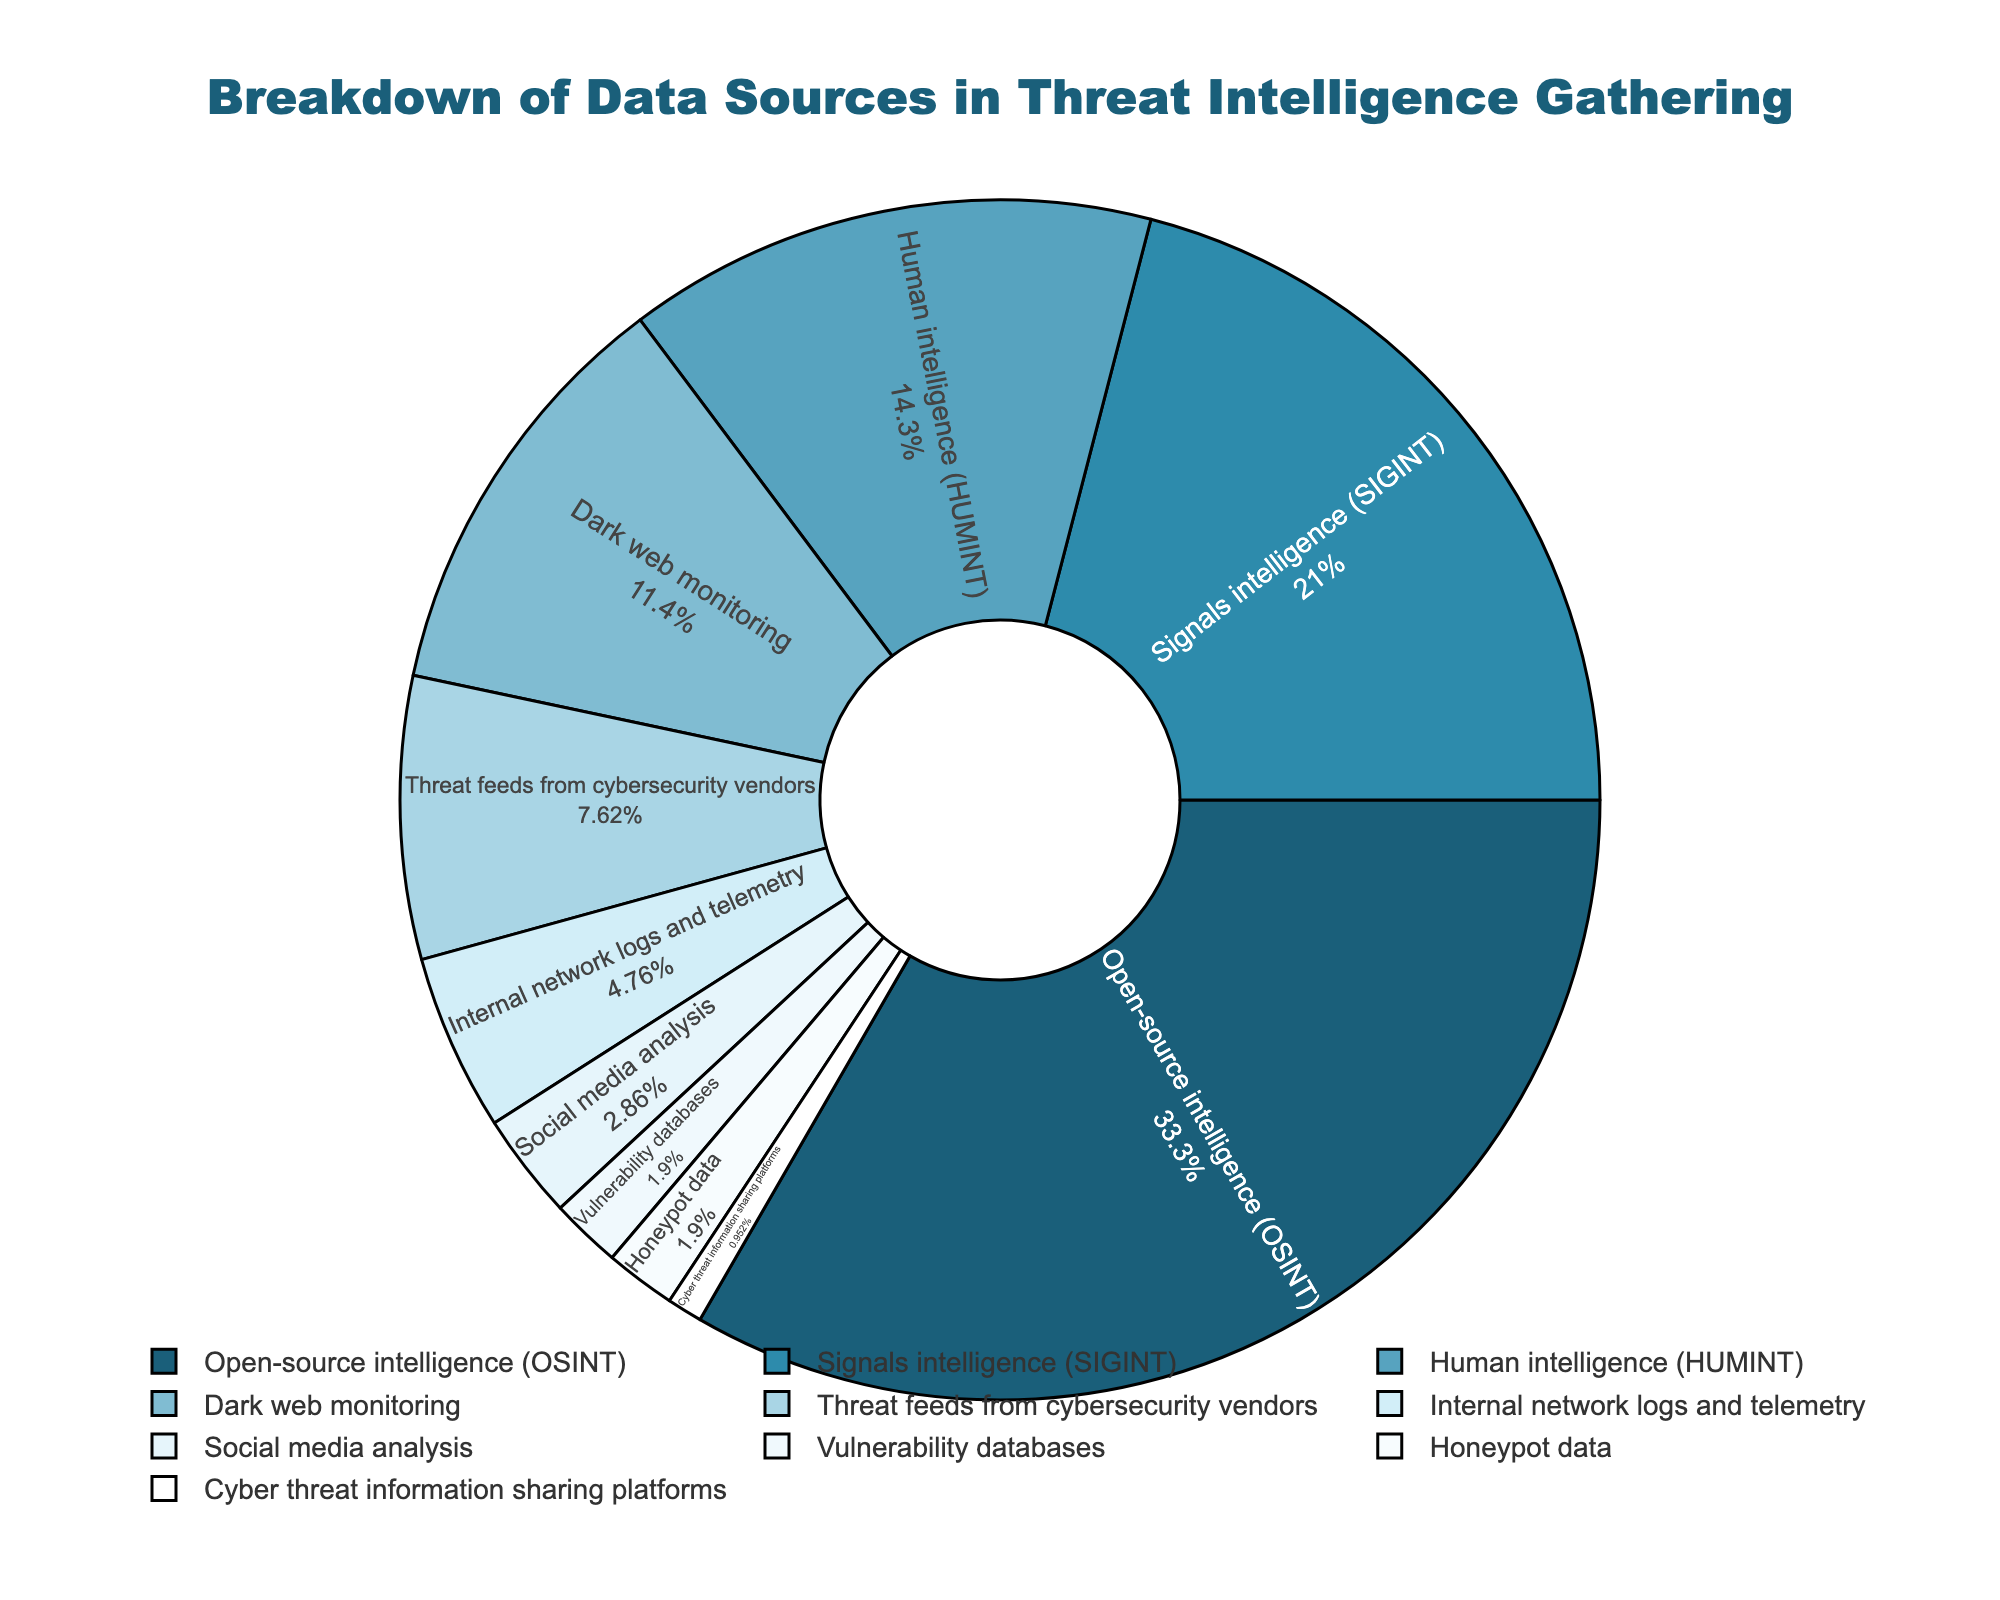What is the largest data source used in threat intelligence gathering? The pie chart shows the breakdown of different data sources. The segment with the largest percentage is Open-source intelligence (OSINT) at 35%.
Answer: Open-source intelligence (OSINT) Which data source has the smallest contribution, and what is its percentage? According to the pie chart, Cyber threat information sharing platforms have the smallest contribution with a percentage of 1%.
Answer: Cyber threat information sharing platforms, 1% What is the combined percentage of signals intelligence (SIGINT) and human intelligence (HUMINT)? The pie chart shows that SIGINT has a percentage of 22% and HUMINT has a percentage of 15%. Adding these two values gives 22% + 15% = 37%.
Answer: 37% How does the contribution of dark web monitoring compare to that of social media analysis? The pie chart indicates that dark web monitoring has a percentage of 12%, while social media analysis has a percentage of 3%. Dark web monitoring contributes more.
Answer: Dark web monitoring contributes more (12% vs. 3%) Which three data sources together make up more than 50% of the total? By summing up the percentages from the largest data sources: OSINT is 35%, SIGINT is 22%, HUMINT is 15%. Adding these together, 35% + 22% + 15% = 72%, which is more than 50%.
Answer: OSINT, SIGINT, HUMINT What is the difference in percentage between threat feeds from cybersecurity vendors and internal network logs and telemetry? The pie chart shows that threat feeds from cybersecurity vendors have a percentage of 8% and internal network logs and telemetry have a percentage of 5%. The difference is 8% - 5% = 3%.
Answer: 3% How does the contribution of vulnerability databases compare to that of honeypot data? The pie chart shows that both vulnerability databases and honeypot data have the same percentage, each at 2%. Their contributions are equal.
Answer: Equal contributions (2% each) What percentage of the data sources combined are from internal network logs and telemetry, social media analysis, vulnerability databases, honeypot data, and cyber threat information sharing platforms? The pie chart lists these percentages: internal network logs and telemetry 5%, social media analysis 3%, vulnerability databases 2%, honeypot data 2%, and cyber threat information sharing platforms 1%. Summing these gives 5% + 3% + 2% + 2% + 1% = 13%.
Answer: 13% What's the combined percentage of dark web monitoring and threat feeds from cybersecurity vendors? According to the pie chart, dark web monitoring is 12% and threat feeds from cybersecurity vendors are 8%. Adding these together gives 12% + 8% = 20%.
Answer: 20% In terms of color, which visual attribute is associated with signals intelligence (SIGINT) in the pie chart? The pie chart shows each segment in different color hues. SIGINT is associated with the second darkest hue in the color palette.
Answer: Second darkest hue 